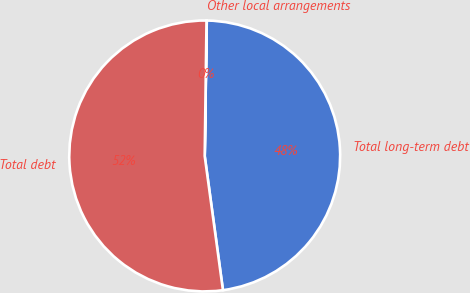<chart> <loc_0><loc_0><loc_500><loc_500><pie_chart><fcel>Total long-term debt<fcel>Other local arrangements<fcel>Total debt<nl><fcel>47.6%<fcel>0.03%<fcel>52.36%<nl></chart> 